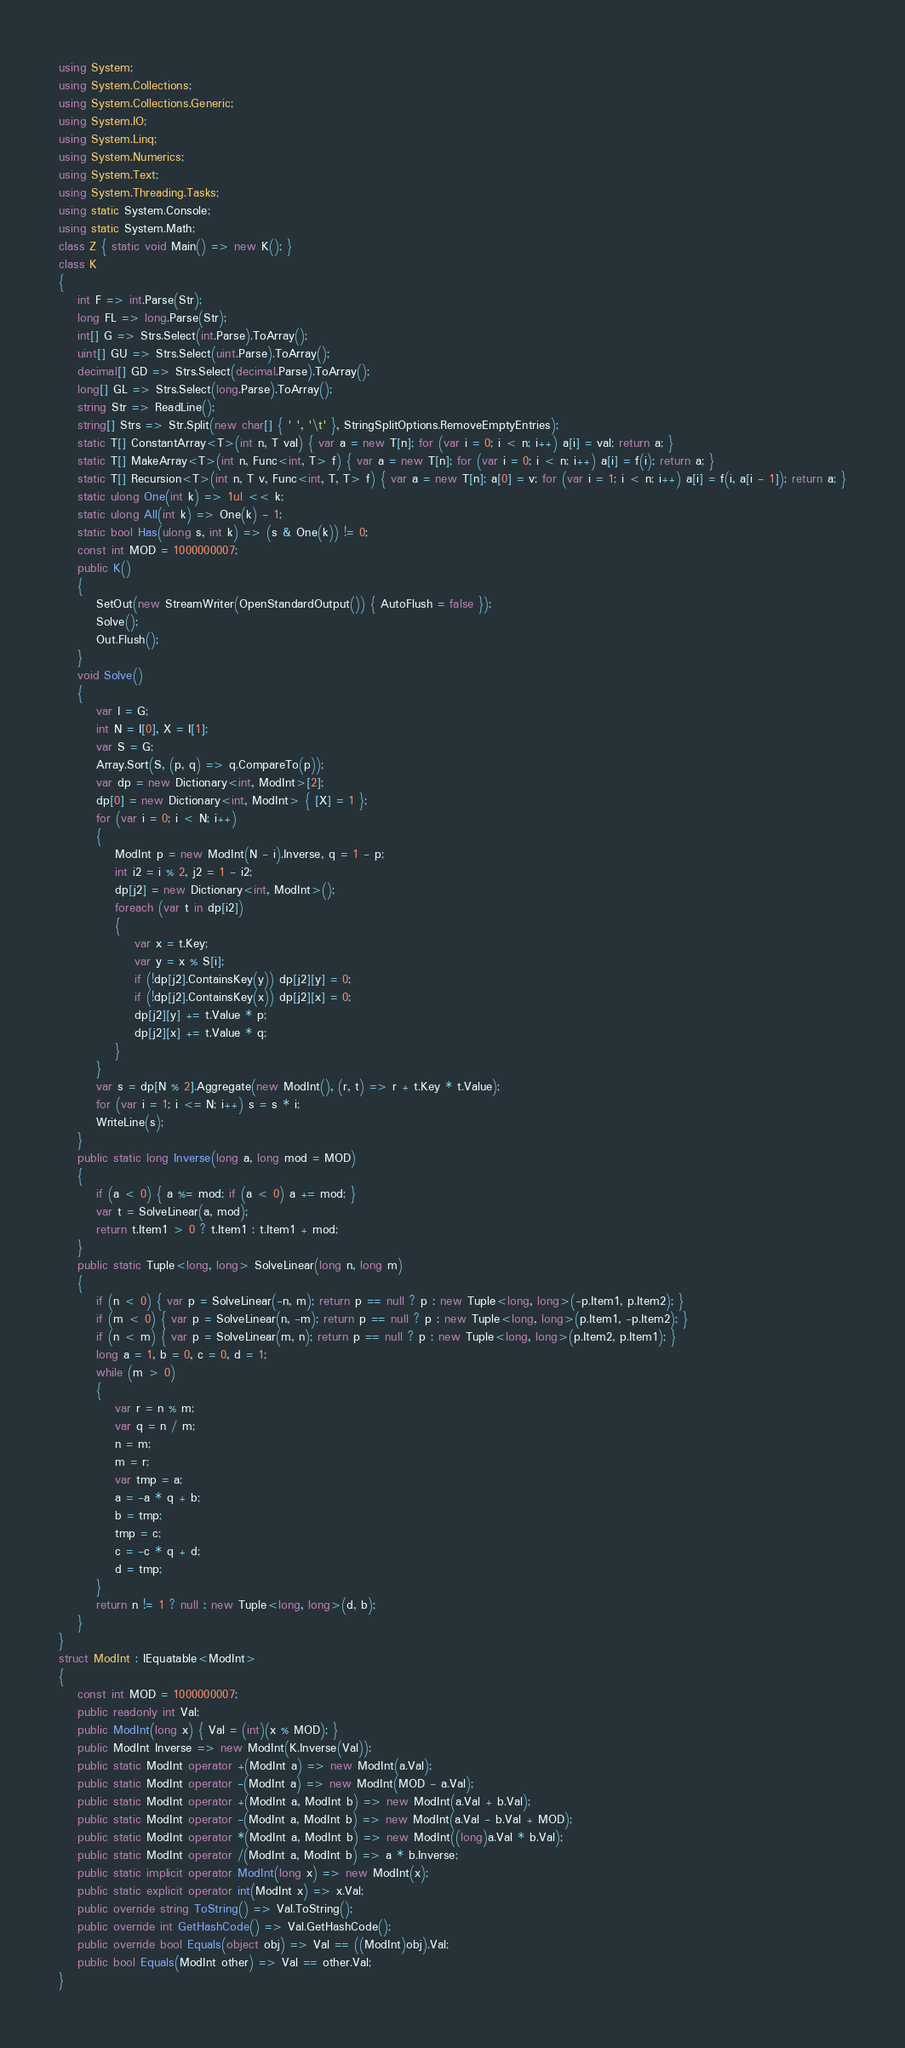<code> <loc_0><loc_0><loc_500><loc_500><_C#_>using System;
using System.Collections;
using System.Collections.Generic;
using System.IO;
using System.Linq;
using System.Numerics;
using System.Text;
using System.Threading.Tasks;
using static System.Console;
using static System.Math;
class Z { static void Main() => new K(); }
class K
{
	int F => int.Parse(Str);
	long FL => long.Parse(Str);
	int[] G => Strs.Select(int.Parse).ToArray();
	uint[] GU => Strs.Select(uint.Parse).ToArray();
	decimal[] GD => Strs.Select(decimal.Parse).ToArray();
	long[] GL => Strs.Select(long.Parse).ToArray();
	string Str => ReadLine();
	string[] Strs => Str.Split(new char[] { ' ', '\t' }, StringSplitOptions.RemoveEmptyEntries);
	static T[] ConstantArray<T>(int n, T val) { var a = new T[n]; for (var i = 0; i < n; i++) a[i] = val; return a; }
	static T[] MakeArray<T>(int n, Func<int, T> f) { var a = new T[n]; for (var i = 0; i < n; i++) a[i] = f(i); return a; }
	static T[] Recursion<T>(int n, T v, Func<int, T, T> f) { var a = new T[n]; a[0] = v; for (var i = 1; i < n; i++) a[i] = f(i, a[i - 1]); return a; }
	static ulong One(int k) => 1ul << k;
	static ulong All(int k) => One(k) - 1;
	static bool Has(ulong s, int k) => (s & One(k)) != 0;
	const int MOD = 1000000007;
	public K()
	{
		SetOut(new StreamWriter(OpenStandardOutput()) { AutoFlush = false });
		Solve();
		Out.Flush();
	}
	void Solve()
	{
		var I = G;
		int N = I[0], X = I[1];
		var S = G;
		Array.Sort(S, (p, q) => q.CompareTo(p));
		var dp = new Dictionary<int, ModInt>[2];
		dp[0] = new Dictionary<int, ModInt> { [X] = 1 };
		for (var i = 0; i < N; i++)
		{
			ModInt p = new ModInt(N - i).Inverse, q = 1 - p;
			int i2 = i % 2, j2 = 1 - i2;
			dp[j2] = new Dictionary<int, ModInt>();
			foreach (var t in dp[i2])
			{
				var x = t.Key;
				var y = x % S[i];
				if (!dp[j2].ContainsKey(y)) dp[j2][y] = 0;
				if (!dp[j2].ContainsKey(x)) dp[j2][x] = 0;
				dp[j2][y] += t.Value * p;
				dp[j2][x] += t.Value * q;
			}
		}
		var s = dp[N % 2].Aggregate(new ModInt(), (r, t) => r + t.Key * t.Value);
		for (var i = 1; i <= N; i++) s = s * i;
		WriteLine(s);
	}
	public static long Inverse(long a, long mod = MOD)
	{
		if (a < 0) { a %= mod; if (a < 0) a += mod; }
		var t = SolveLinear(a, mod);
		return t.Item1 > 0 ? t.Item1 : t.Item1 + mod;
	}
	public static Tuple<long, long> SolveLinear(long n, long m)
	{
		if (n < 0) { var p = SolveLinear(-n, m); return p == null ? p : new Tuple<long, long>(-p.Item1, p.Item2); }
		if (m < 0) { var p = SolveLinear(n, -m); return p == null ? p : new Tuple<long, long>(p.Item1, -p.Item2); }
		if (n < m) { var p = SolveLinear(m, n); return p == null ? p : new Tuple<long, long>(p.Item2, p.Item1); }
		long a = 1, b = 0, c = 0, d = 1;
		while (m > 0)
		{
			var r = n % m;
			var q = n / m;
			n = m;
			m = r;
			var tmp = a;
			a = -a * q + b;
			b = tmp;
			tmp = c;
			c = -c * q + d;
			d = tmp;
		}
		return n != 1 ? null : new Tuple<long, long>(d, b);
	}
}
struct ModInt : IEquatable<ModInt>
{
	const int MOD = 1000000007;
	public readonly int Val;
	public ModInt(long x) { Val = (int)(x % MOD); }
	public ModInt Inverse => new ModInt(K.Inverse(Val));
	public static ModInt operator +(ModInt a) => new ModInt(a.Val);
	public static ModInt operator -(ModInt a) => new ModInt(MOD - a.Val);
	public static ModInt operator +(ModInt a, ModInt b) => new ModInt(a.Val + b.Val);
	public static ModInt operator -(ModInt a, ModInt b) => new ModInt(a.Val - b.Val + MOD);
	public static ModInt operator *(ModInt a, ModInt b) => new ModInt((long)a.Val * b.Val);
	public static ModInt operator /(ModInt a, ModInt b) => a * b.Inverse;
	public static implicit operator ModInt(long x) => new ModInt(x);
	public static explicit operator int(ModInt x) => x.Val;
	public override string ToString() => Val.ToString();
	public override int GetHashCode() => Val.GetHashCode();
	public override bool Equals(object obj) => Val == ((ModInt)obj).Val;
	public bool Equals(ModInt other) => Val == other.Val;
}</code> 